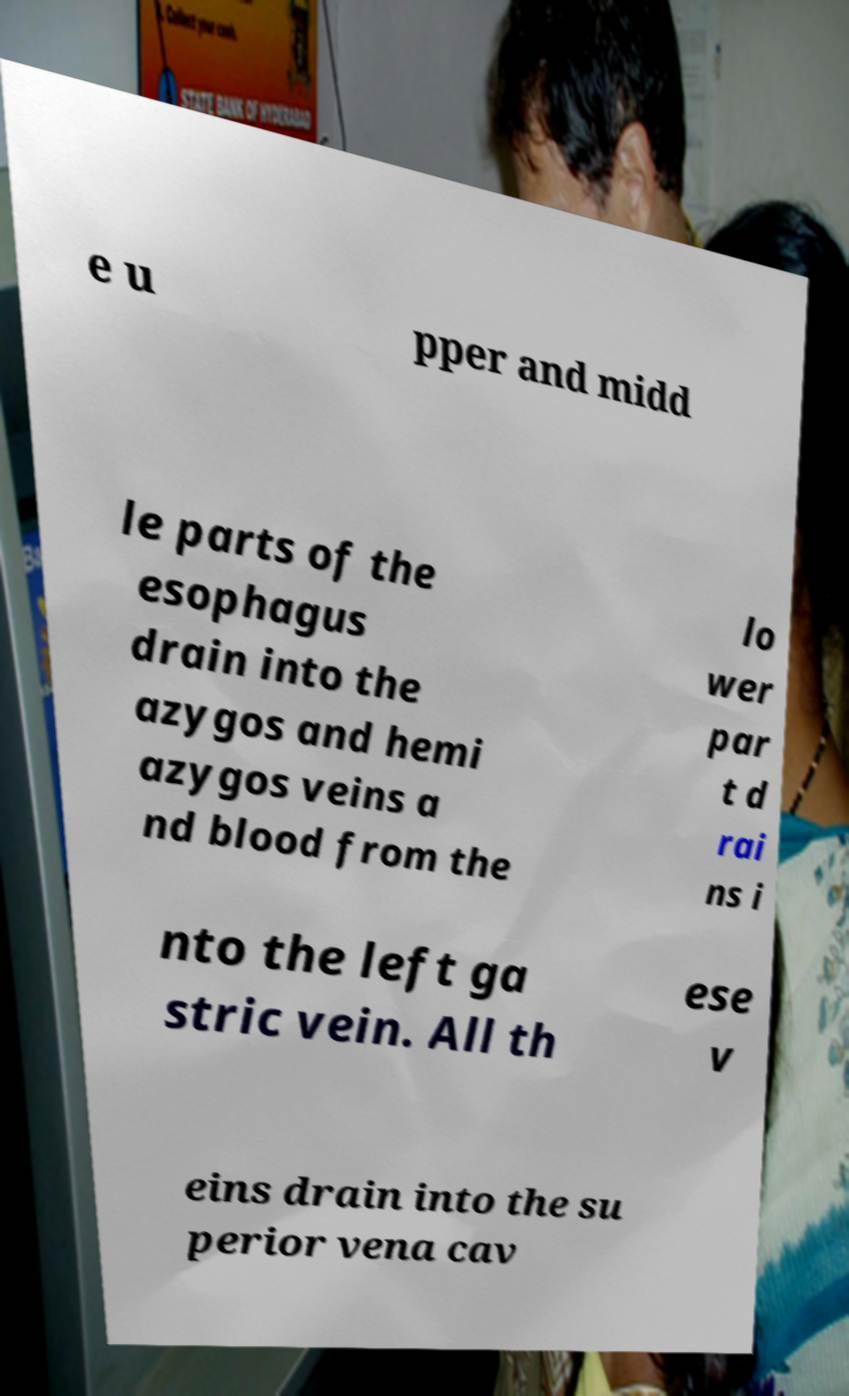Could you assist in decoding the text presented in this image and type it out clearly? e u pper and midd le parts of the esophagus drain into the azygos and hemi azygos veins a nd blood from the lo wer par t d rai ns i nto the left ga stric vein. All th ese v eins drain into the su perior vena cav 